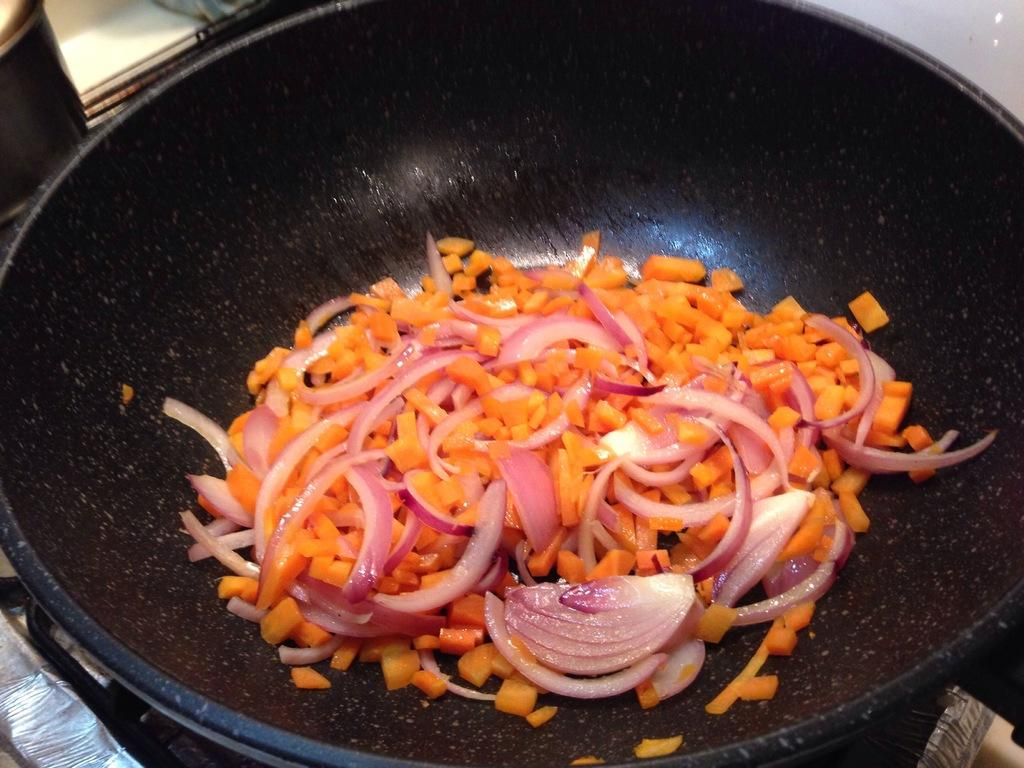What is on the stove in the image? There is a pin on the stove in the image. What type of vegetable can be seen in the image? There are chopped carrot pieces in the image. What other type of vegetable can be seen in the image? There are chopped onion pieces in the image. What type of clouds can be seen in the image? There are no clouds present in the image; it features a pin on the stove and chopped vegetables. What does the mom say about the property in the image? There is no reference to a mom or property in the image, so it's not possible to determine what she might say. 